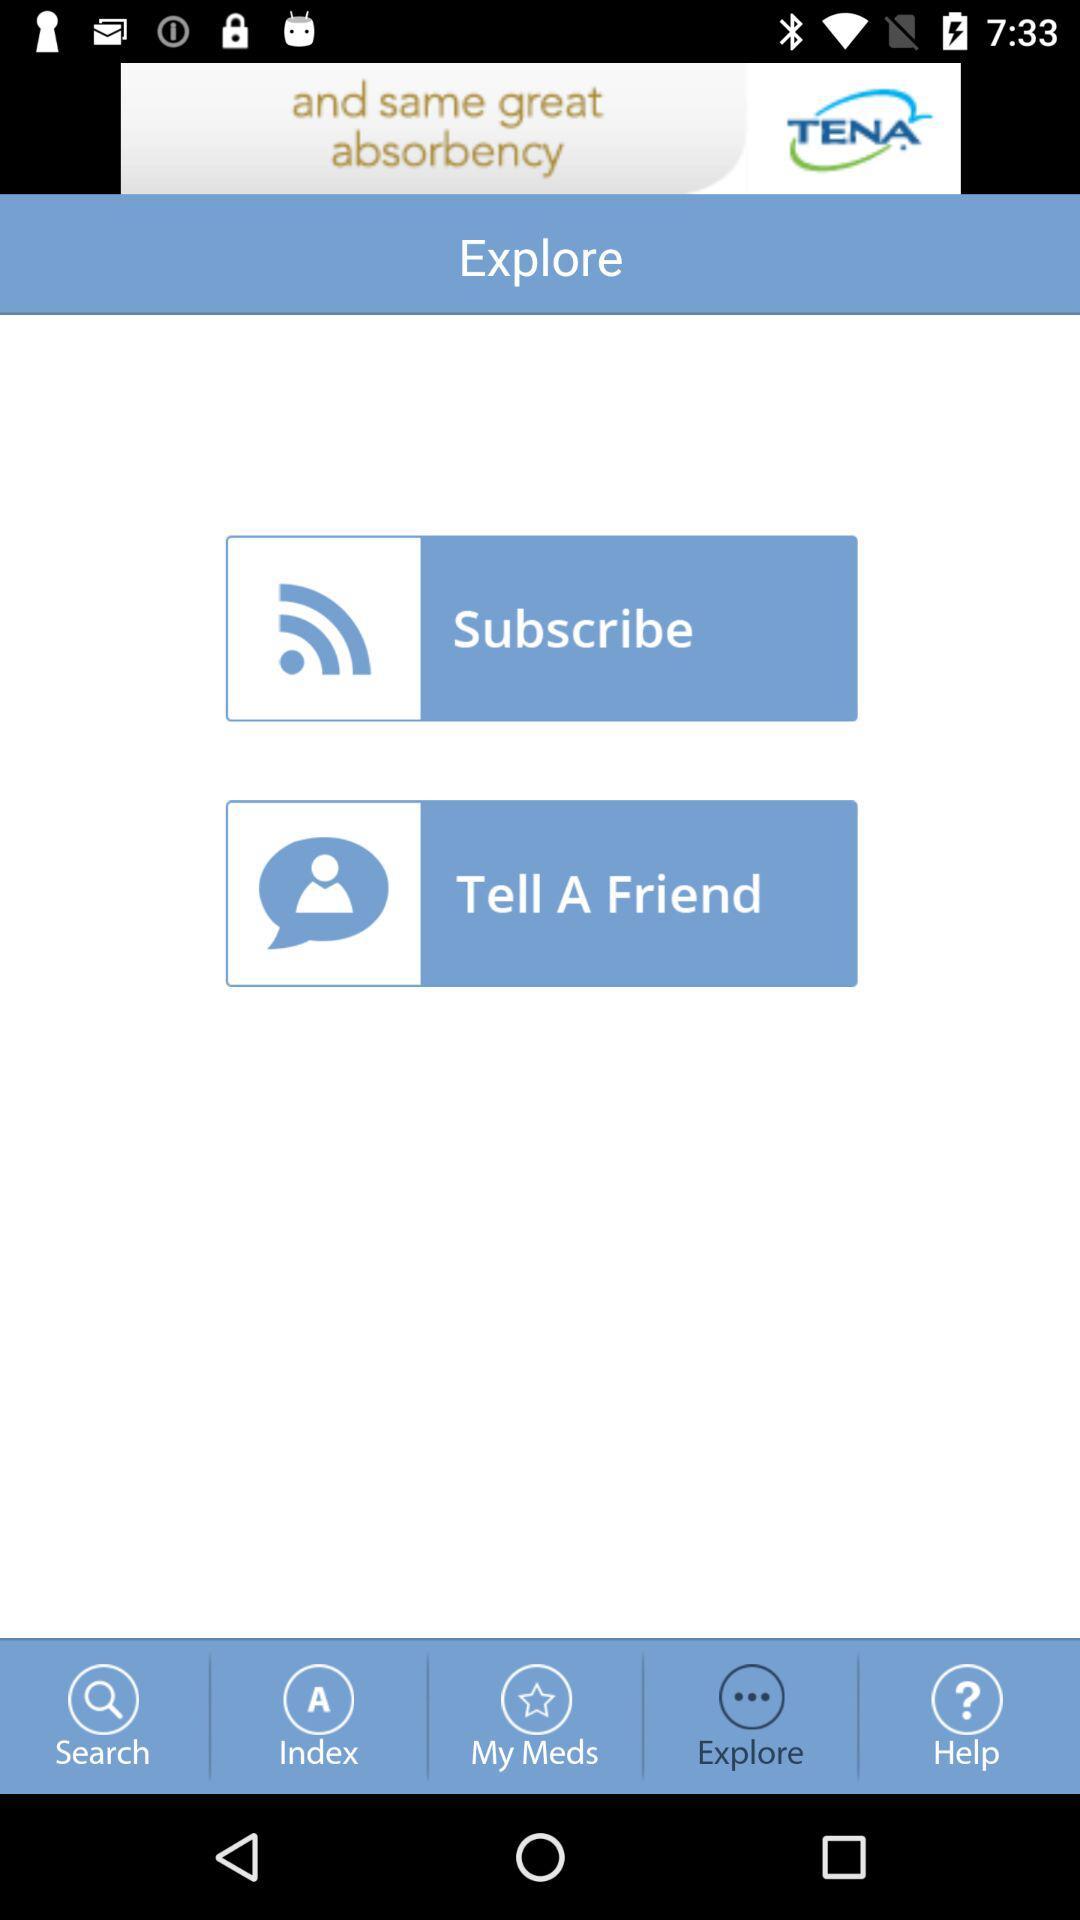Which tab am I on? You are on the "Explore" tab. 